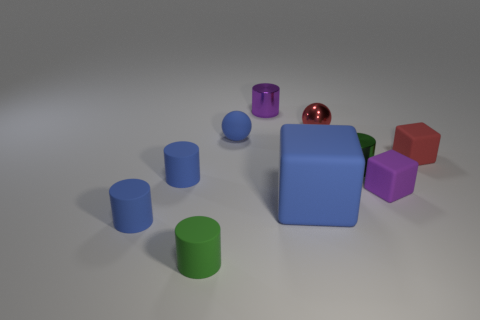Subtract all purple cylinders. How many cylinders are left? 4 Subtract all tiny green matte cylinders. How many cylinders are left? 4 Subtract all red cylinders. Subtract all yellow balls. How many cylinders are left? 5 Subtract all cubes. How many objects are left? 7 Subtract all purple blocks. Subtract all balls. How many objects are left? 7 Add 6 green objects. How many green objects are left? 8 Add 9 large brown metal objects. How many large brown metal objects exist? 9 Subtract 0 cyan blocks. How many objects are left? 10 